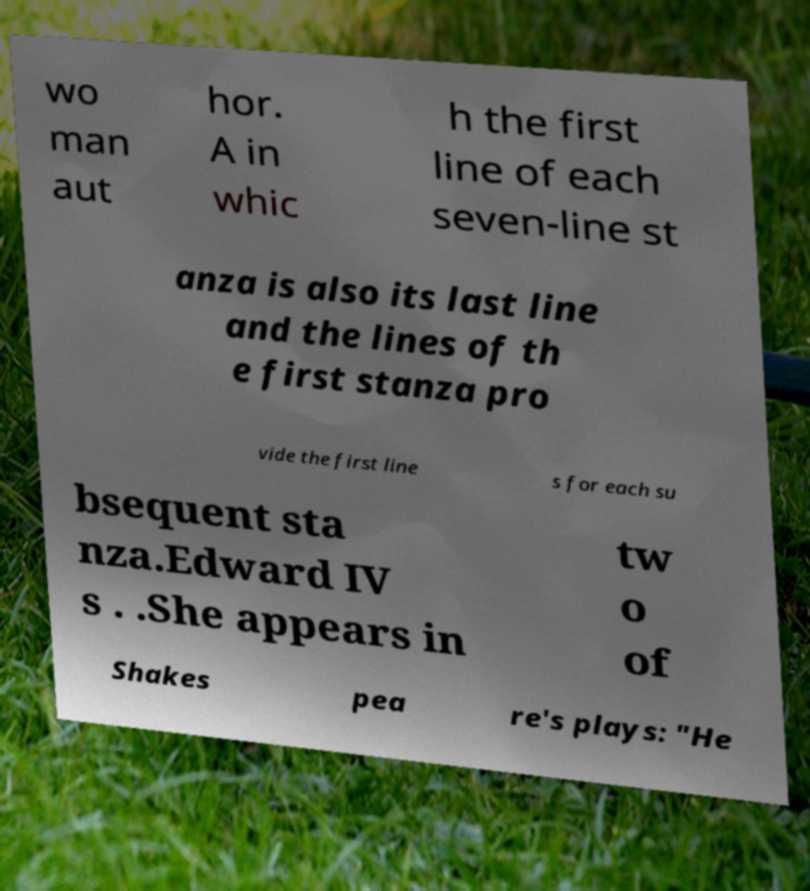Could you extract and type out the text from this image? wo man aut hor. A in whic h the first line of each seven-line st anza is also its last line and the lines of th e first stanza pro vide the first line s for each su bsequent sta nza.Edward IV s . .She appears in tw o of Shakes pea re's plays: "He 